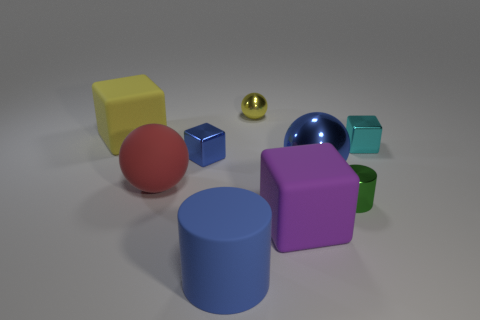Subtract 1 cubes. How many cubes are left? 3 Subtract all spheres. How many objects are left? 6 Add 3 yellow metal objects. How many yellow metal objects are left? 4 Add 3 large blue rubber cylinders. How many large blue rubber cylinders exist? 4 Subtract 0 brown balls. How many objects are left? 9 Subtract all large brown matte things. Subtract all blue metal blocks. How many objects are left? 8 